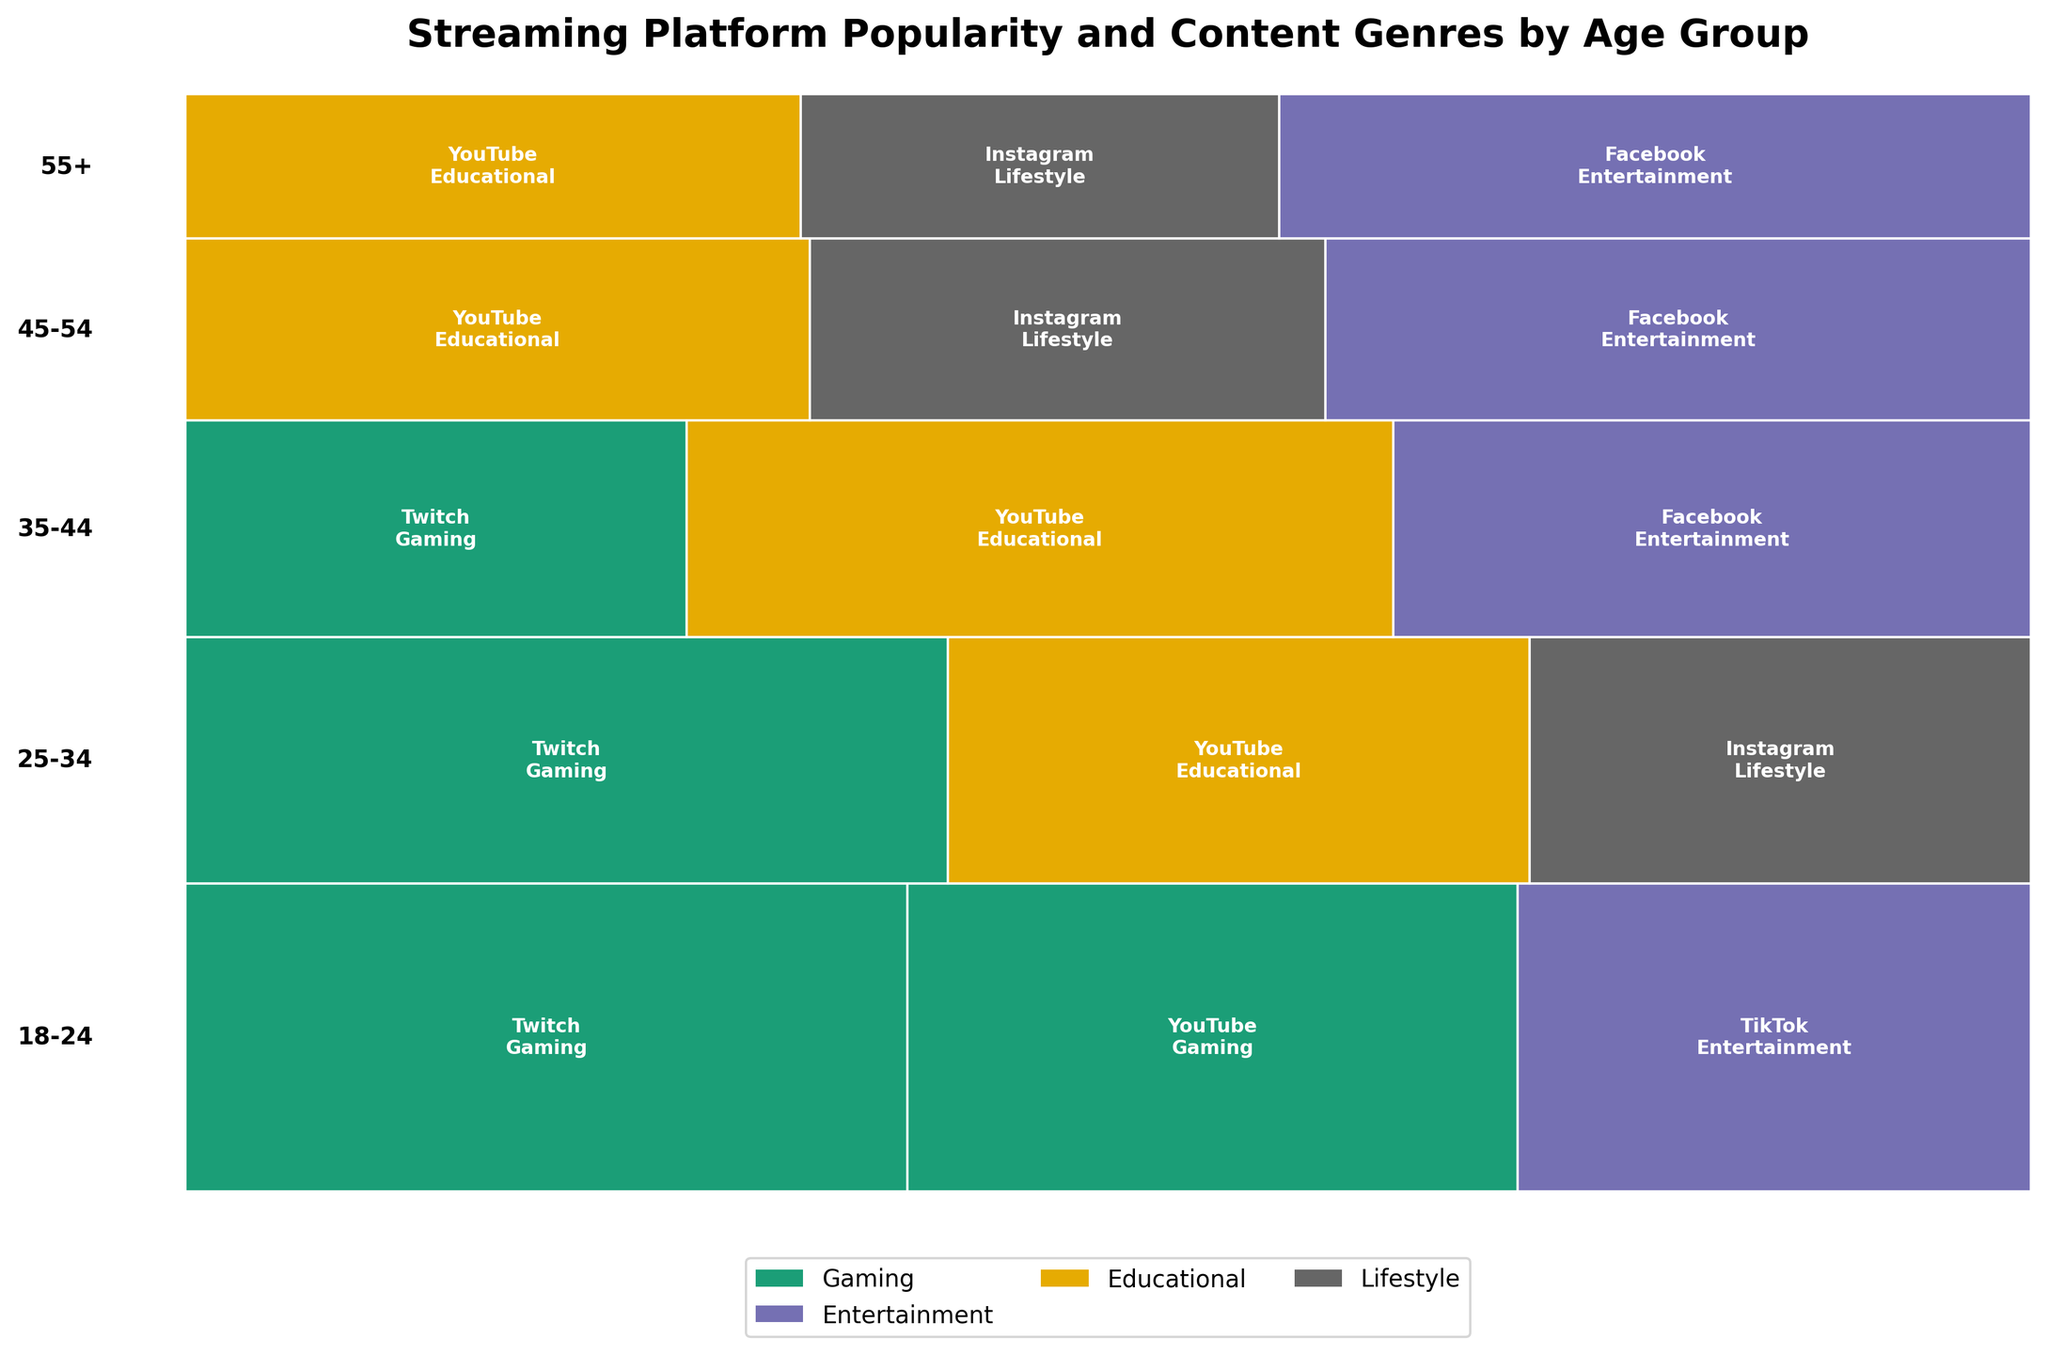What's the title of the figure? The title is displayed at the top of the figure, providing an overview of the data presented.
Answer: Streaming Platform Popularity and Content Genres by Age Group Which age group has the highest count for Twitch in the Gaming genre? The age groups and their corresponding platforms and genres are represented by the rectangles. The largest rectangle for Twitch and Gaming indicates the highest count.
Answer: 18-24 What is the preferred genre for age group 55+ on Facebook? By looking at the largest rectangle corresponding to 55+ and Facebook, the genre associated with it can be identified.
Answer: Entertainment Compare the popularity of Gaming on Twitch between age groups 18-24 and 25-34. Which age group has a higher count? Locate the rectangles for Twitch and Gaming in both age groups, and compare their sizes. The larger rectangle signifies a higher count.
Answer: 18-24 Which platform and genre combination is least represented in the age group 35-44? Identify the smallest rectangle within the age group 35-44, noting the associated platform and genre.
Answer: Twitch, Gaming How does the popularity of YouTube for the Educational genre differ between age groups 25-34 and 45-54? Compare the sizes of the rectangles representing YouTube and Educational for both age groups. The relative sizes indicate the differences in popularity.
Answer: 25-34 has higher popularity What's the combined total count for Twitch across all age groups? Sum the counts of Twitch across all age groups: (450 + 380 + 220)
Answer: 1050 What are the primary content genres consumed by age group 18-24, based on platform popularity? Examine the rectangles in the age group 18-24 and note the genres associated with the most prominent platforms.
Answer: Gaming, Entertainment How does the content preference of the age group 35-44 on YouTube compare with that of the age group 45-54? Check the genres associated with YouTube in both age groups and compare their sizes. This indicates whether the preferences are similar or different.
Answer: Both prefer Educational 